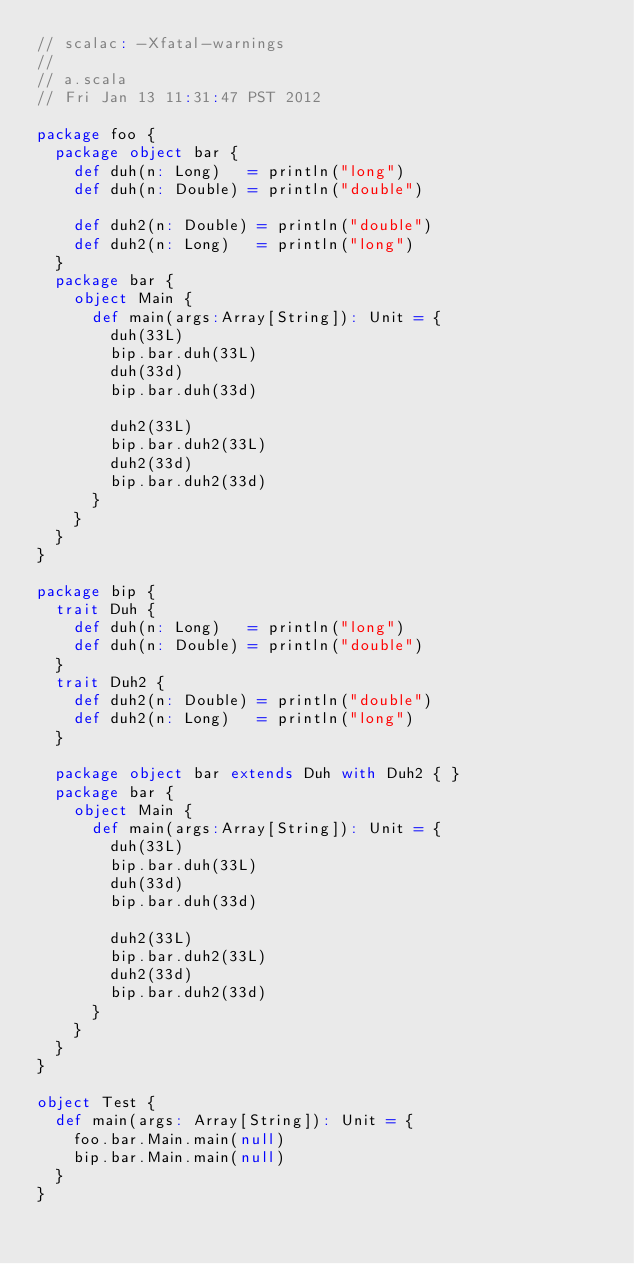<code> <loc_0><loc_0><loc_500><loc_500><_Scala_>// scalac: -Xfatal-warnings
//
// a.scala
// Fri Jan 13 11:31:47 PST 2012

package foo {
  package object bar {
    def duh(n: Long)   = println("long")
    def duh(n: Double) = println("double")

    def duh2(n: Double) = println("double")
    def duh2(n: Long)   = println("long")
  }
  package bar {
    object Main {
      def main(args:Array[String]): Unit = {
        duh(33L)
        bip.bar.duh(33L)
        duh(33d)
        bip.bar.duh(33d)

        duh2(33L)
        bip.bar.duh2(33L)
        duh2(33d)
        bip.bar.duh2(33d)
      }
    }
  }
}

package bip {
  trait Duh {
    def duh(n: Long)   = println("long")
    def duh(n: Double) = println("double")
  }
  trait Duh2 {
    def duh2(n: Double) = println("double")
    def duh2(n: Long)   = println("long")
  }

  package object bar extends Duh with Duh2 { }
  package bar {
    object Main {
      def main(args:Array[String]): Unit = {
        duh(33L)
        bip.bar.duh(33L)
        duh(33d)
        bip.bar.duh(33d)

        duh2(33L)
        bip.bar.duh2(33L)
        duh2(33d)
        bip.bar.duh2(33d)
      }
    }
  }
}

object Test {
  def main(args: Array[String]): Unit = {
    foo.bar.Main.main(null)
    bip.bar.Main.main(null)
  }
}
</code> 